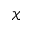Convert formula to latex. <formula><loc_0><loc_0><loc_500><loc_500>\mathcal { X }</formula> 